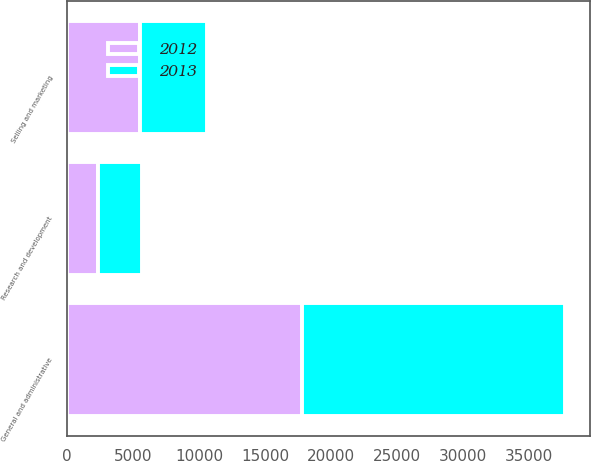Convert chart to OTSL. <chart><loc_0><loc_0><loc_500><loc_500><stacked_bar_chart><ecel><fcel>Selling and marketing<fcel>General and administrative<fcel>Research and development<nl><fcel>2012<fcel>5562<fcel>17824<fcel>2319<nl><fcel>2013<fcel>5042<fcel>19963<fcel>3345<nl></chart> 